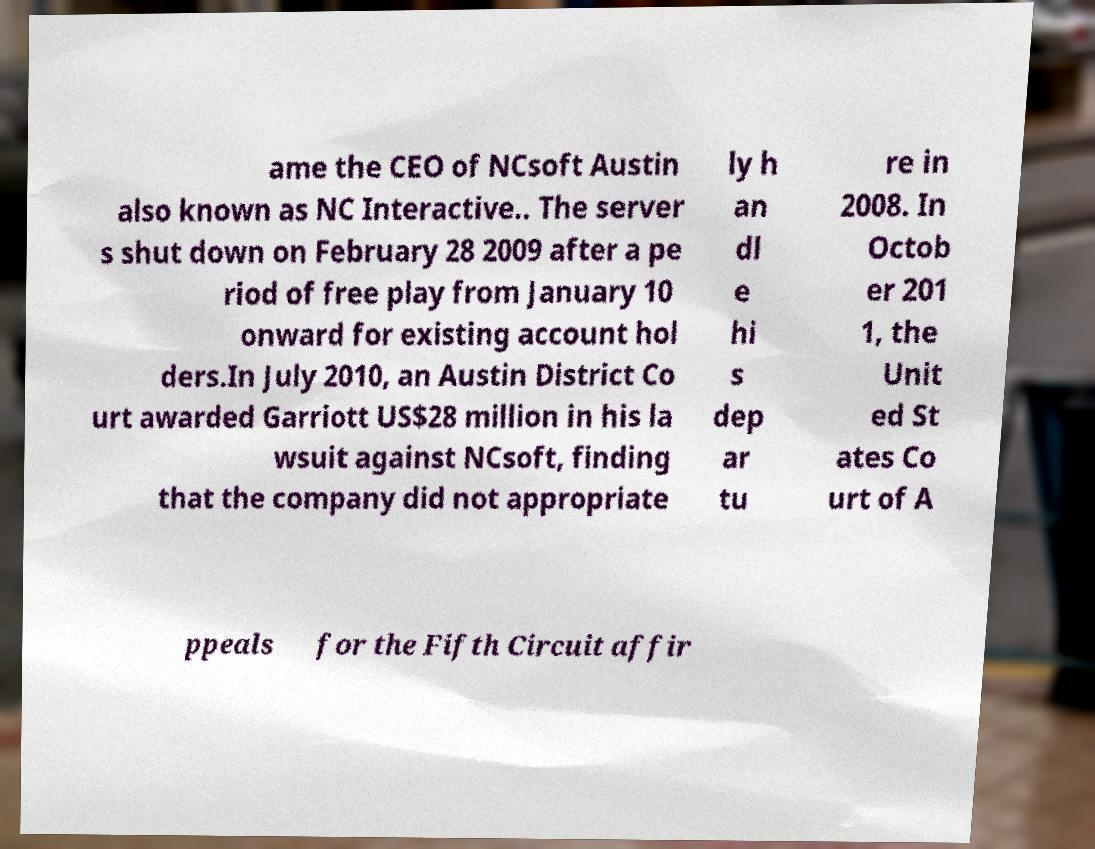I need the written content from this picture converted into text. Can you do that? ame the CEO of NCsoft Austin also known as NC Interactive.. The server s shut down on February 28 2009 after a pe riod of free play from January 10 onward for existing account hol ders.In July 2010, an Austin District Co urt awarded Garriott US$28 million in his la wsuit against NCsoft, finding that the company did not appropriate ly h an dl e hi s dep ar tu re in 2008. In Octob er 201 1, the Unit ed St ates Co urt of A ppeals for the Fifth Circuit affir 